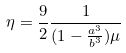<formula> <loc_0><loc_0><loc_500><loc_500>\eta = \frac { 9 } { 2 } \frac { 1 } { ( 1 - \frac { a ^ { 3 } } { b ^ { 3 } } ) \mu }</formula> 